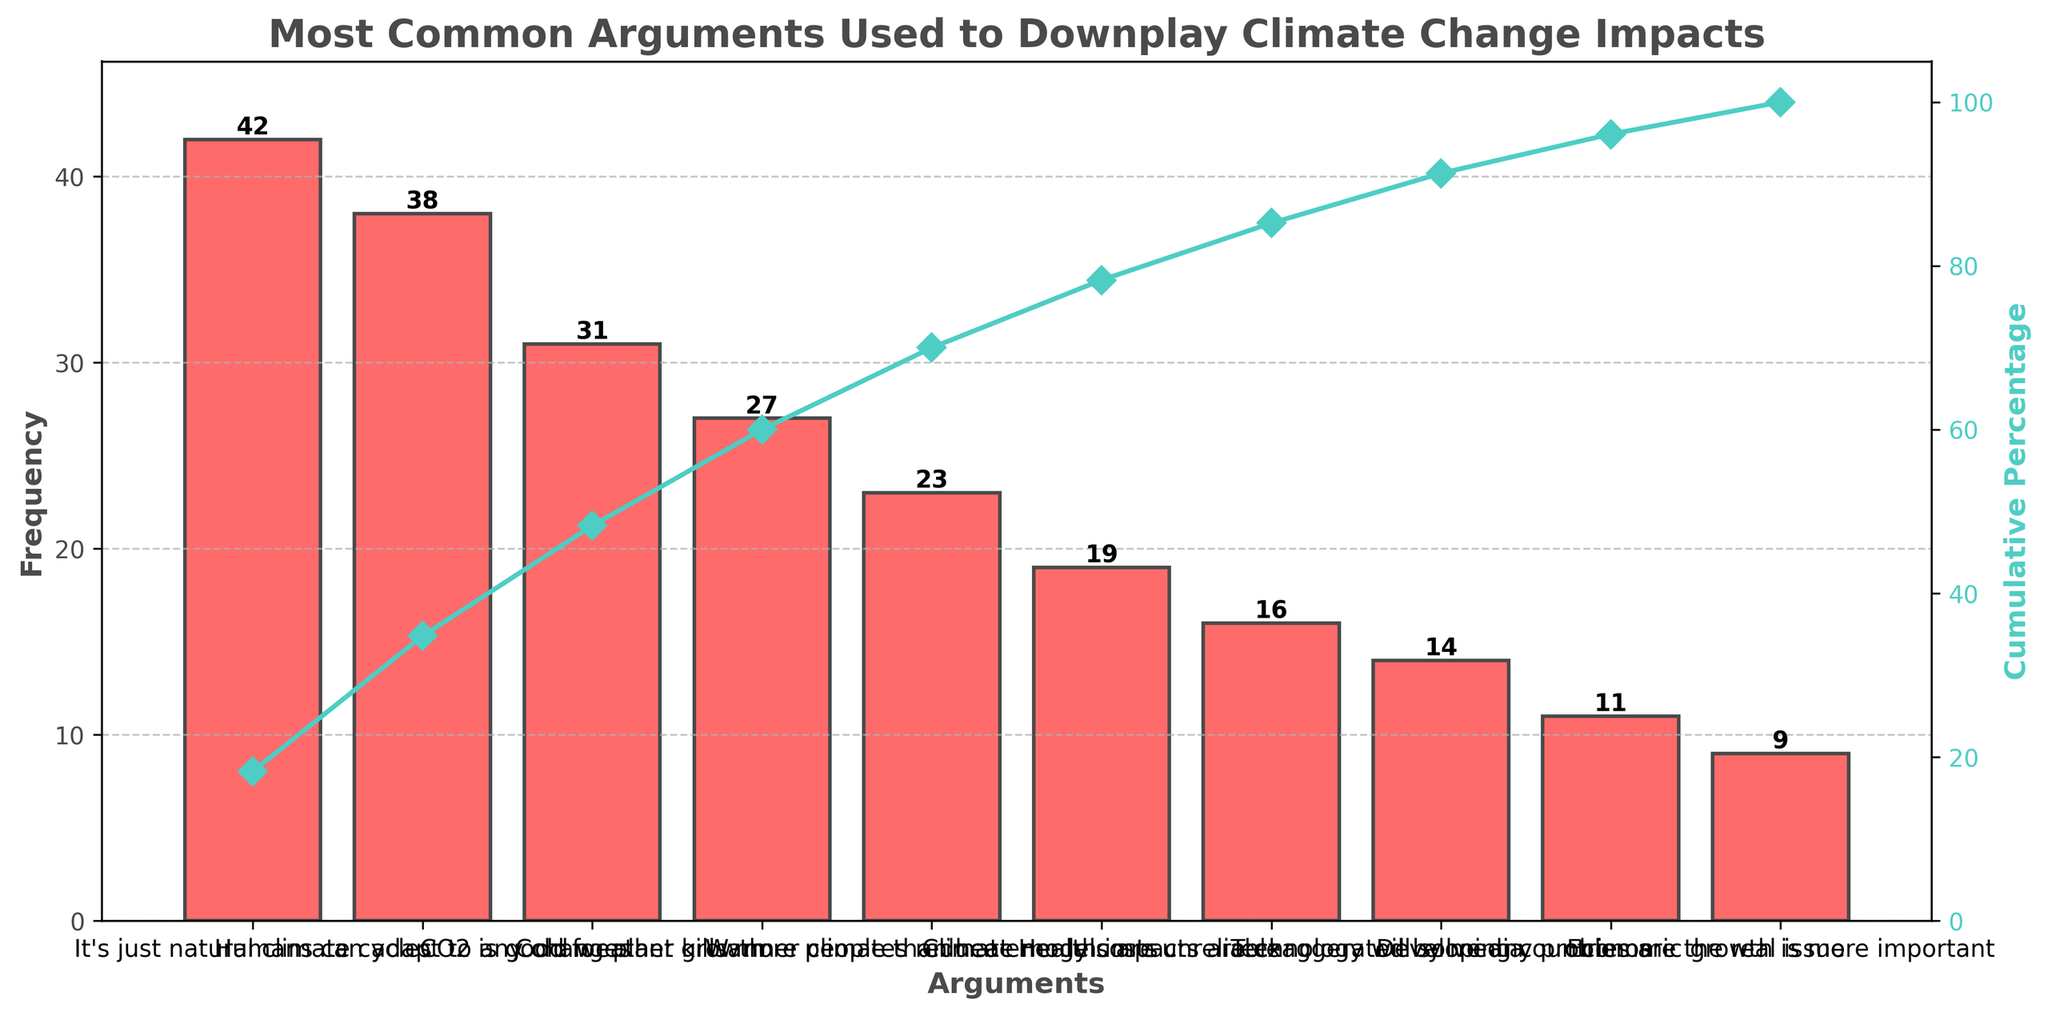What is the title of the figure? The title of the figure is usually placed at the top and describes the overall purpose of the chart. Here, it says, "Most Common Arguments Used to Downplay Climate Change Impacts."
Answer: Most Common Arguments Used to Downplay Climate Change Impacts What is the most common argument used to downplay climate change impacts? The most common argument is represented by the tallest bar in the chart. Here, the tallest bar corresponds to the argument "It's just natural climate cycles" with a frequency of 42.
Answer: "It's just natural climate cycles" Which argument is associated with a frequency of 19? To find the argument with a frequency of 19, we look at the height of the bars in the chart. The bar with a frequency of 19 corresponds to the argument "Climate models are unreliable."
Answer: "Climate models are unreliable" How many arguments have a frequency of more than 20? To determine the number of arguments with a frequency greater than 20, count the bars with heights exceeding the value of 20. These arguments are: "It's just natural climate cycles," "Humans can adapt to any changes," "CO2 is good for plant growth," "Cold weather kills more people than heat," and "Warmer climates reduce energy costs."
Answer: 5 What is the cumulative percentage at the bar labeled "Cold weather kills more people than heat"? The cumulative percentage can be seen as the line plot. At the "Cold weather kills more people than heat" bar, the cumulative percentage value is approximately 73% based on its position in the line plot.
Answer: ~73% Is "Economic growth is more important" one of the top five common arguments? To answer this, we need to see if "Economic growth is more important" appears among the first five bars sorted by height. It does not; this argument is one of the shorter bars near the end.
Answer: No How does the frequency of the argument "Technology will solve any problems" compare to "Humans can adapt to any changes"? To make this comparison, look at the bar heights of both arguments. "Technology will solve any problems" has a frequency of 14, whereas "Humans can adapt to any changes" has a higher frequency of 38.
Answer: Less than Which arguments contribute to over 50% of the cumulative percentage? To find this, we follow the cumulative percentage line to the point where it slightly exceeds 50%. The arguments contributing to this are "It's just natural climate cycles" and "Humans can adapt to any changes," with their cumulative percentage around 55%.
Answer: "It's just natural climate cycles" and "Humans can adapt to any changes" What is the frequency range of the arguments listed? The frequency range is determined by the difference between the highest and lowest values. The highest frequency is 42 ("It's just natural climate cycles"), and the lowest frequency is 9 ("Economic growth is more important"). Therefore, the range is 42 - 9 = 33.
Answer: 33 How many arguments have a frequency of less than 20? To find this number, count the arguments represented by bars with heights less than 20. These arguments are: "Health impacts are exaggerated by media," "Technology will solve any problems," "Developing countries are the real issue," and "Economic growth is more important." There are 4 such arguments.
Answer: 4 